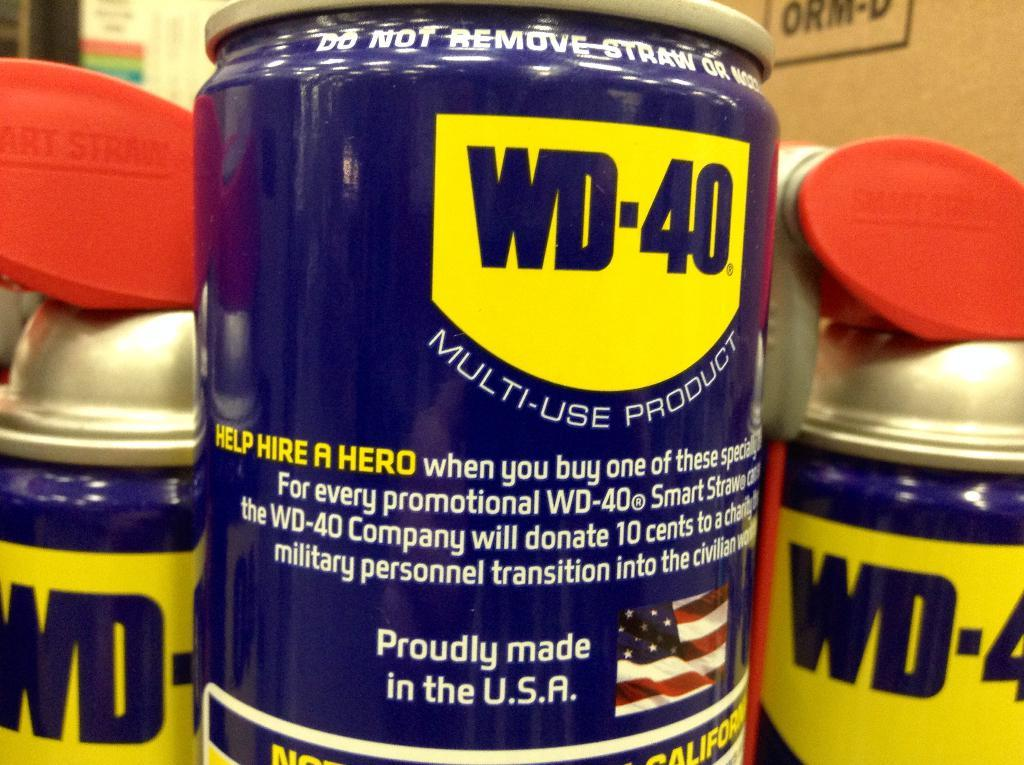<image>
Relay a brief, clear account of the picture shown. a close up shot of a wd-40 can next to others 